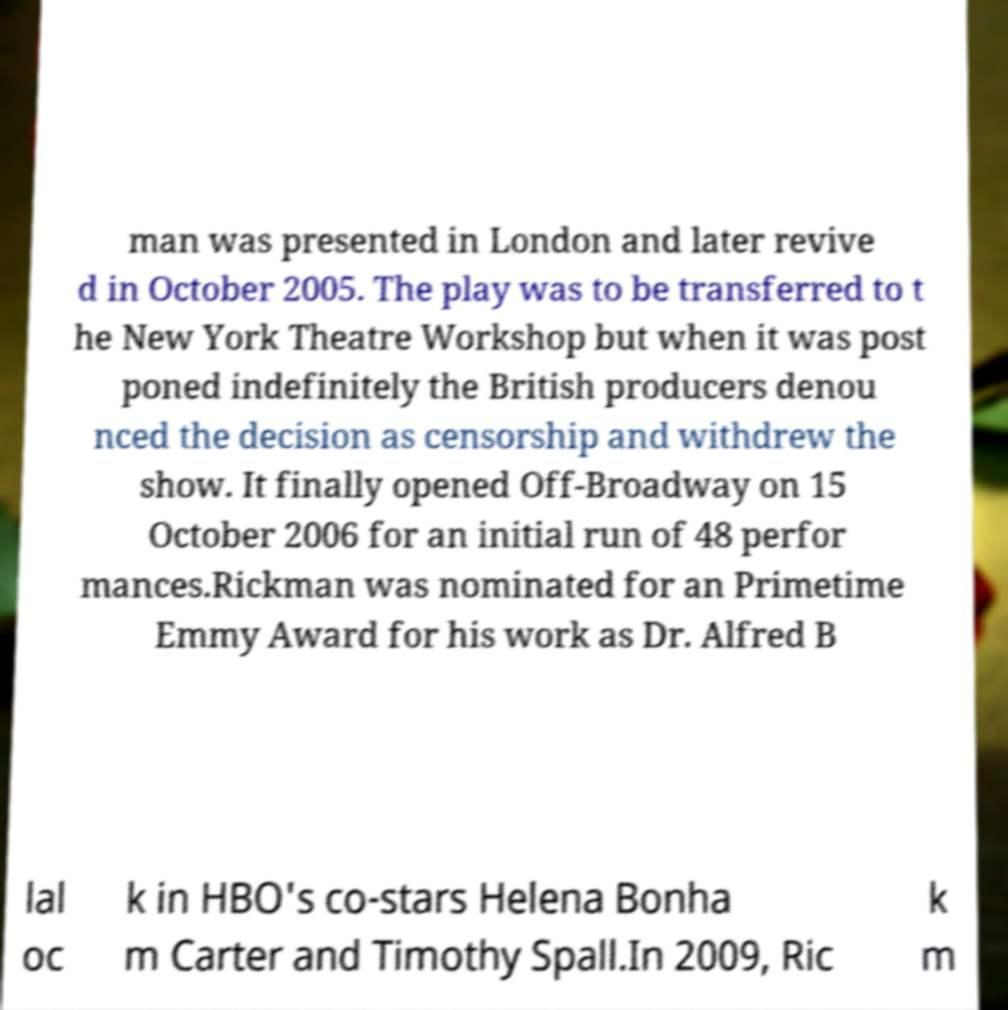Could you extract and type out the text from this image? man was presented in London and later revive d in October 2005. The play was to be transferred to t he New York Theatre Workshop but when it was post poned indefinitely the British producers denou nced the decision as censorship and withdrew the show. It finally opened Off-Broadway on 15 October 2006 for an initial run of 48 perfor mances.Rickman was nominated for an Primetime Emmy Award for his work as Dr. Alfred B lal oc k in HBO's co-stars Helena Bonha m Carter and Timothy Spall.In 2009, Ric k m 